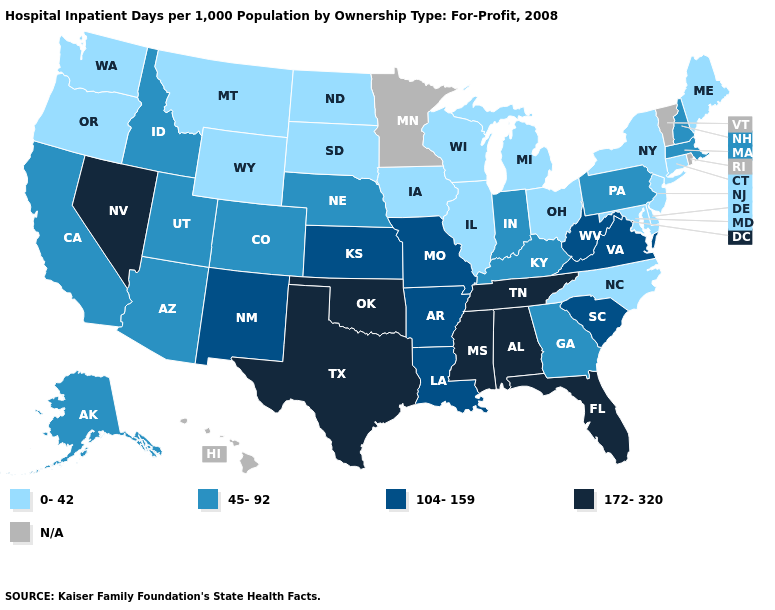Name the states that have a value in the range 172-320?
Answer briefly. Alabama, Florida, Mississippi, Nevada, Oklahoma, Tennessee, Texas. Name the states that have a value in the range 172-320?
Be succinct. Alabama, Florida, Mississippi, Nevada, Oklahoma, Tennessee, Texas. Name the states that have a value in the range 45-92?
Keep it brief. Alaska, Arizona, California, Colorado, Georgia, Idaho, Indiana, Kentucky, Massachusetts, Nebraska, New Hampshire, Pennsylvania, Utah. Does the map have missing data?
Be succinct. Yes. Does Oklahoma have the highest value in the USA?
Be succinct. Yes. What is the value of Wyoming?
Quick response, please. 0-42. What is the lowest value in the South?
Concise answer only. 0-42. What is the value of Rhode Island?
Answer briefly. N/A. Among the states that border Kansas , does Nebraska have the highest value?
Short answer required. No. Does Kentucky have the lowest value in the USA?
Concise answer only. No. Name the states that have a value in the range 0-42?
Quick response, please. Connecticut, Delaware, Illinois, Iowa, Maine, Maryland, Michigan, Montana, New Jersey, New York, North Carolina, North Dakota, Ohio, Oregon, South Dakota, Washington, Wisconsin, Wyoming. Name the states that have a value in the range 45-92?
Quick response, please. Alaska, Arizona, California, Colorado, Georgia, Idaho, Indiana, Kentucky, Massachusetts, Nebraska, New Hampshire, Pennsylvania, Utah. Does the map have missing data?
Be succinct. Yes. Among the states that border New Mexico , which have the lowest value?
Write a very short answer. Arizona, Colorado, Utah. 